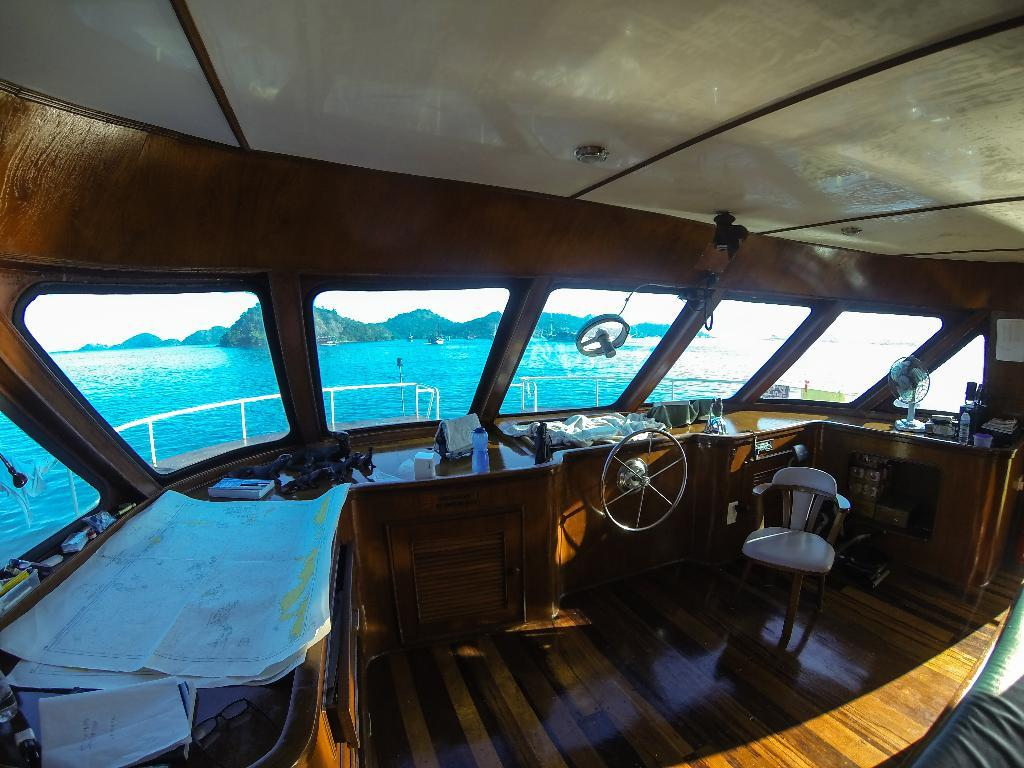What type of location is depicted in the image? The image shows an inside view of a boat. What can be seen outside the boat in the image? There is water visible in the image. What type of landscape can be seen in the distance? There are mountains visible in the image. Where are the scissors placed in the image? There are no scissors present in the image. How many spiders can be seen crawling on the boat in the image? There are no spiders present in the image. 